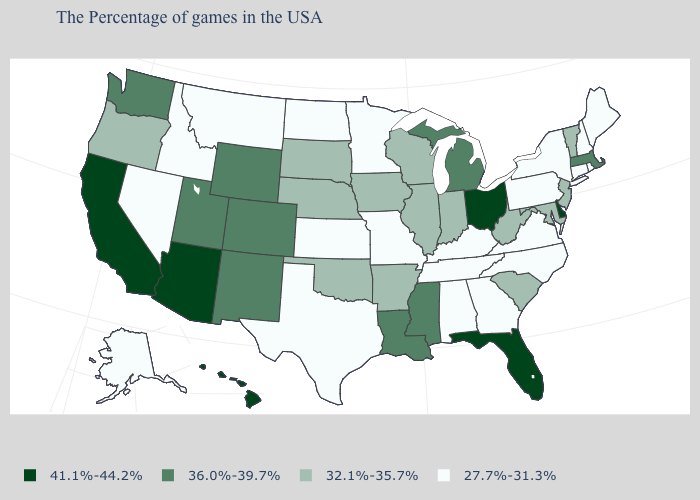Is the legend a continuous bar?
Write a very short answer. No. What is the value of Indiana?
Give a very brief answer. 32.1%-35.7%. What is the value of Maine?
Keep it brief. 27.7%-31.3%. What is the highest value in the USA?
Quick response, please. 41.1%-44.2%. What is the value of South Dakota?
Answer briefly. 32.1%-35.7%. What is the highest value in the South ?
Keep it brief. 41.1%-44.2%. What is the value of Arkansas?
Write a very short answer. 32.1%-35.7%. Does Connecticut have a lower value than Virginia?
Answer briefly. No. Among the states that border California , which have the lowest value?
Short answer required. Nevada. What is the value of Louisiana?
Keep it brief. 36.0%-39.7%. Name the states that have a value in the range 41.1%-44.2%?
Concise answer only. Delaware, Ohio, Florida, Arizona, California, Hawaii. Name the states that have a value in the range 36.0%-39.7%?
Give a very brief answer. Massachusetts, Michigan, Mississippi, Louisiana, Wyoming, Colorado, New Mexico, Utah, Washington. Does Tennessee have the same value as Indiana?
Quick response, please. No. Does Alaska have the lowest value in the West?
Be succinct. Yes. Name the states that have a value in the range 36.0%-39.7%?
Keep it brief. Massachusetts, Michigan, Mississippi, Louisiana, Wyoming, Colorado, New Mexico, Utah, Washington. 